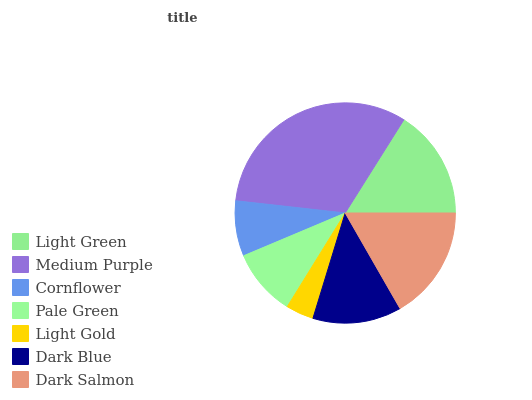Is Light Gold the minimum?
Answer yes or no. Yes. Is Medium Purple the maximum?
Answer yes or no. Yes. Is Cornflower the minimum?
Answer yes or no. No. Is Cornflower the maximum?
Answer yes or no. No. Is Medium Purple greater than Cornflower?
Answer yes or no. Yes. Is Cornflower less than Medium Purple?
Answer yes or no. Yes. Is Cornflower greater than Medium Purple?
Answer yes or no. No. Is Medium Purple less than Cornflower?
Answer yes or no. No. Is Dark Blue the high median?
Answer yes or no. Yes. Is Dark Blue the low median?
Answer yes or no. Yes. Is Medium Purple the high median?
Answer yes or no. No. Is Pale Green the low median?
Answer yes or no. No. 